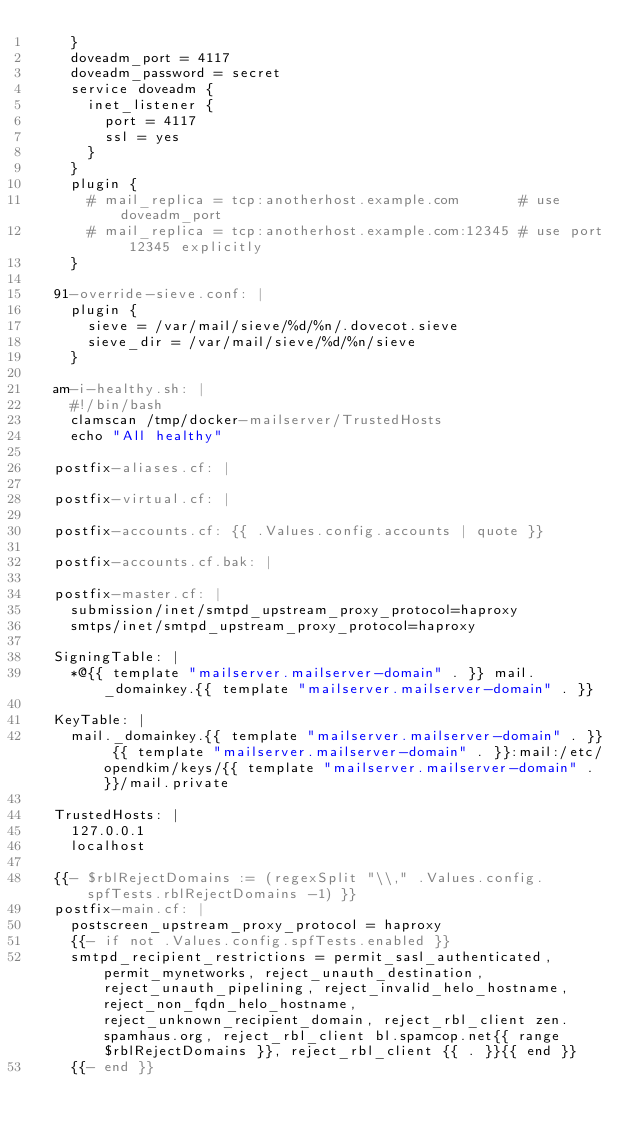Convert code to text. <code><loc_0><loc_0><loc_500><loc_500><_YAML_>    }
    doveadm_port = 4117
    doveadm_password = secret
    service doveadm {
      inet_listener {
        port = 4117
        ssl = yes
      }
    }
    plugin {
      # mail_replica = tcp:anotherhost.example.com       # use doveadm_port
      # mail_replica = tcp:anotherhost.example.com:12345 # use port 12345 explicitly
    }

  91-override-sieve.conf: |
    plugin {
      sieve = /var/mail/sieve/%d/%n/.dovecot.sieve
      sieve_dir = /var/mail/sieve/%d/%n/sieve
    }

  am-i-healthy.sh: |
    #!/bin/bash
    clamscan /tmp/docker-mailserver/TrustedHosts
    echo "All healthy"

  postfix-aliases.cf: |

  postfix-virtual.cf: |

  postfix-accounts.cf: {{ .Values.config.accounts | quote }}

  postfix-accounts.cf.bak: |

  postfix-master.cf: |
    submission/inet/smtpd_upstream_proxy_protocol=haproxy
    smtps/inet/smtpd_upstream_proxy_protocol=haproxy

  SigningTable: |
    *@{{ template "mailserver.mailserver-domain" . }} mail._domainkey.{{ template "mailserver.mailserver-domain" . }}

  KeyTable: |
    mail._domainkey.{{ template "mailserver.mailserver-domain" . }} {{ template "mailserver.mailserver-domain" . }}:mail:/etc/opendkim/keys/{{ template "mailserver.mailserver-domain" . }}/mail.private

  TrustedHosts: |
    127.0.0.1
    localhost

  {{- $rblRejectDomains := (regexSplit "\\," .Values.config.spfTests.rblRejectDomains -1) }}
  postfix-main.cf: |
    postscreen_upstream_proxy_protocol = haproxy
    {{- if not .Values.config.spfTests.enabled }}
    smtpd_recipient_restrictions = permit_sasl_authenticated, permit_mynetworks, reject_unauth_destination, reject_unauth_pipelining, reject_invalid_helo_hostname, reject_non_fqdn_helo_hostname, reject_unknown_recipient_domain, reject_rbl_client zen.spamhaus.org, reject_rbl_client bl.spamcop.net{{ range $rblRejectDomains }}, reject_rbl_client {{ . }}{{ end }}
    {{- end }}
</code> 